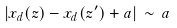<formula> <loc_0><loc_0><loc_500><loc_500>| x _ { d } ( z ) - x _ { d } ( z ^ { \prime } ) + a | \, \sim \, a</formula> 